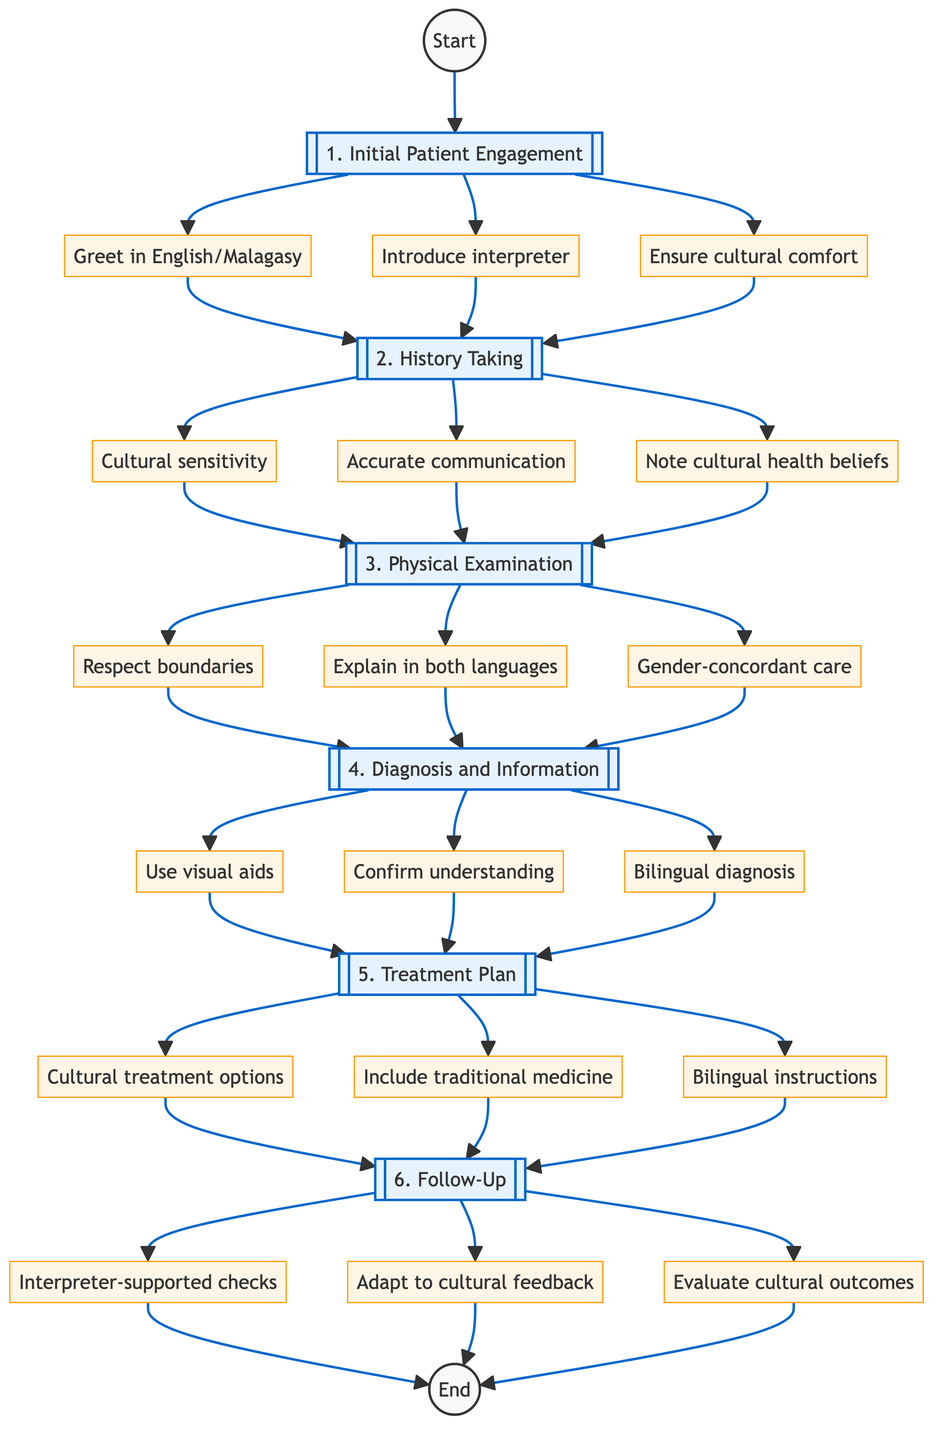What is the first step in the cross-cultural communication pathway? The first step is labeled "1. Initial Patient Engagement," where greeting and introducing interpreter services are essential.
Answer: 1. Initial Patient Engagement How many elements are there in the “Diagnosis and Information Sharing” step? There are three elements in this step: visual aids, confirming understanding, and bilingual diagnosis, as listed under the "4. Diagnosis and Information Sharing" step.
Answer: 3 What should be done to ensure patient comfort? Ensuring patient comfort involves cultural considerations, specifically mentioned under the first step.
Answer: Ensure cultural comfort What language is used to explain each step of the physical examination? Each step of the physical examination should be explained in both English and Malagasy, which is explicitly stated in the "3. Physical Examination" step.
Answer: English and Malagasy Which step involves teaching back to confirm understanding? Teaching back to confirm understanding occurs in the "4. Diagnosis and Information Sharing" step, where the patient ensures they have correctly understood the information shared.
Answer: 4. Diagnosis and Information Sharing What does the treatment plan include for cultural acceptance? The treatment plan includes discussing culturally acceptable treatment options, as mentioned in the "5. Treatment Plan" step.
Answer: Culturally acceptable treatment options In which step is the evaluation of patient outcomes based on cultural context done? The evaluation of patient outcomes considering cultural context is part of the "6. Follow-Up" step, addressing how care is adapted based on cultural feedback.
Answer: 6. Follow-Up Which step includes providing bilingual instructions? Providing bilingual instructions is part of the "5. Treatment Plan," ensuring clarity and understanding for the patient.
Answer: 5. Treatment Plan How should sensitive questions be asked during history taking? Sensitive questions should be asked using cultural understanding, as outlined in the "2. History Taking" step.
Answer: Cultural understanding 